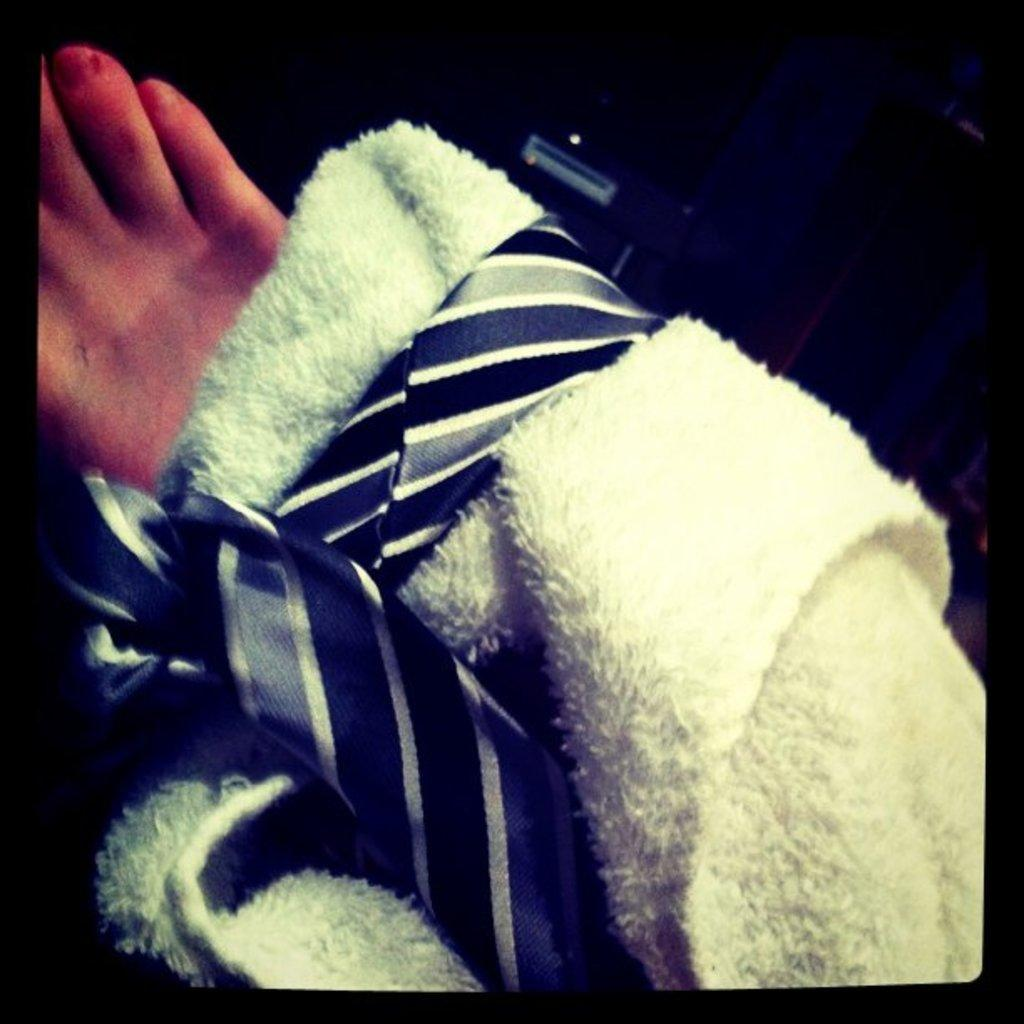What type of clothing accessory is present in the image? There is a tie in the image. What other item can be seen in the image? There is a towel in the image. What part of the body is visible in the image? A leg is visible in the image. How would you describe the overall lighting in the image? The background of the image is dark. What color is the grape that is being held by the person in the image? There is no grape present in the image. How is the string attached to the silver object in the image? There is no string or silver object present in the image. 